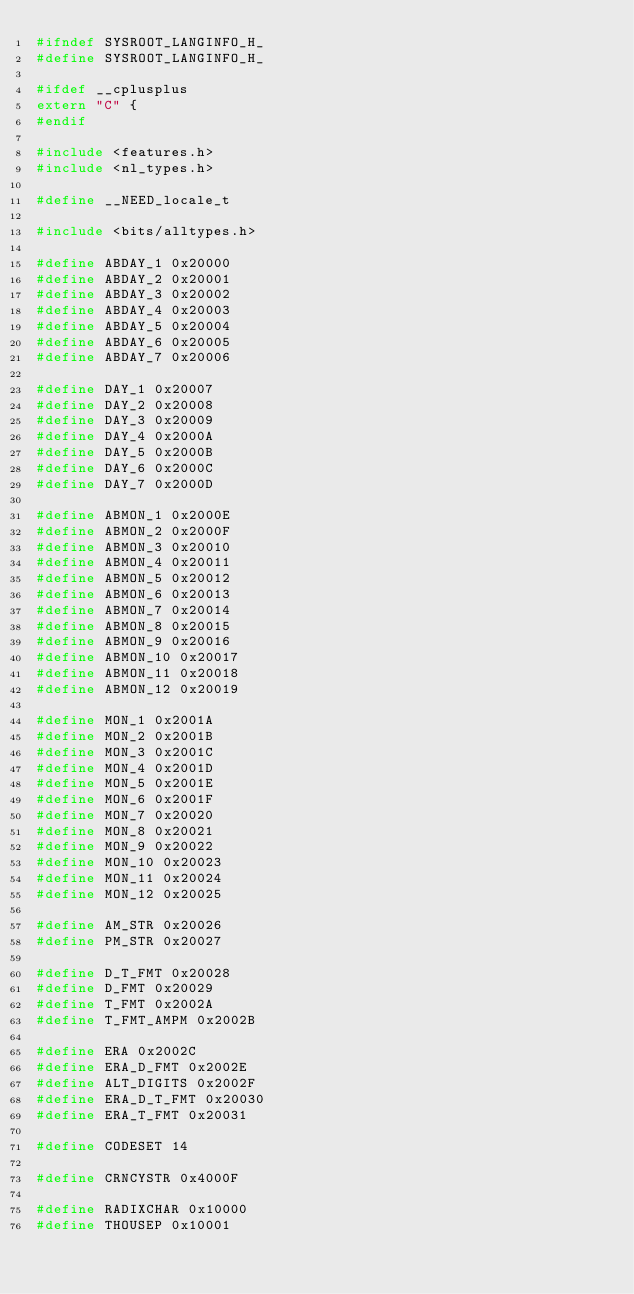Convert code to text. <code><loc_0><loc_0><loc_500><loc_500><_C_>#ifndef SYSROOT_LANGINFO_H_
#define SYSROOT_LANGINFO_H_

#ifdef __cplusplus
extern "C" {
#endif

#include <features.h>
#include <nl_types.h>

#define __NEED_locale_t

#include <bits/alltypes.h>

#define ABDAY_1 0x20000
#define ABDAY_2 0x20001
#define ABDAY_3 0x20002
#define ABDAY_4 0x20003
#define ABDAY_5 0x20004
#define ABDAY_6 0x20005
#define ABDAY_7 0x20006

#define DAY_1 0x20007
#define DAY_2 0x20008
#define DAY_3 0x20009
#define DAY_4 0x2000A
#define DAY_5 0x2000B
#define DAY_6 0x2000C
#define DAY_7 0x2000D

#define ABMON_1 0x2000E
#define ABMON_2 0x2000F
#define ABMON_3 0x20010
#define ABMON_4 0x20011
#define ABMON_5 0x20012
#define ABMON_6 0x20013
#define ABMON_7 0x20014
#define ABMON_8 0x20015
#define ABMON_9 0x20016
#define ABMON_10 0x20017
#define ABMON_11 0x20018
#define ABMON_12 0x20019

#define MON_1 0x2001A
#define MON_2 0x2001B
#define MON_3 0x2001C
#define MON_4 0x2001D
#define MON_5 0x2001E
#define MON_6 0x2001F
#define MON_7 0x20020
#define MON_8 0x20021
#define MON_9 0x20022
#define MON_10 0x20023
#define MON_11 0x20024
#define MON_12 0x20025

#define AM_STR 0x20026
#define PM_STR 0x20027

#define D_T_FMT 0x20028
#define D_FMT 0x20029
#define T_FMT 0x2002A
#define T_FMT_AMPM 0x2002B

#define ERA 0x2002C
#define ERA_D_FMT 0x2002E
#define ALT_DIGITS 0x2002F
#define ERA_D_T_FMT 0x20030
#define ERA_T_FMT 0x20031

#define CODESET 14

#define CRNCYSTR 0x4000F

#define RADIXCHAR 0x10000
#define THOUSEP 0x10001</code> 